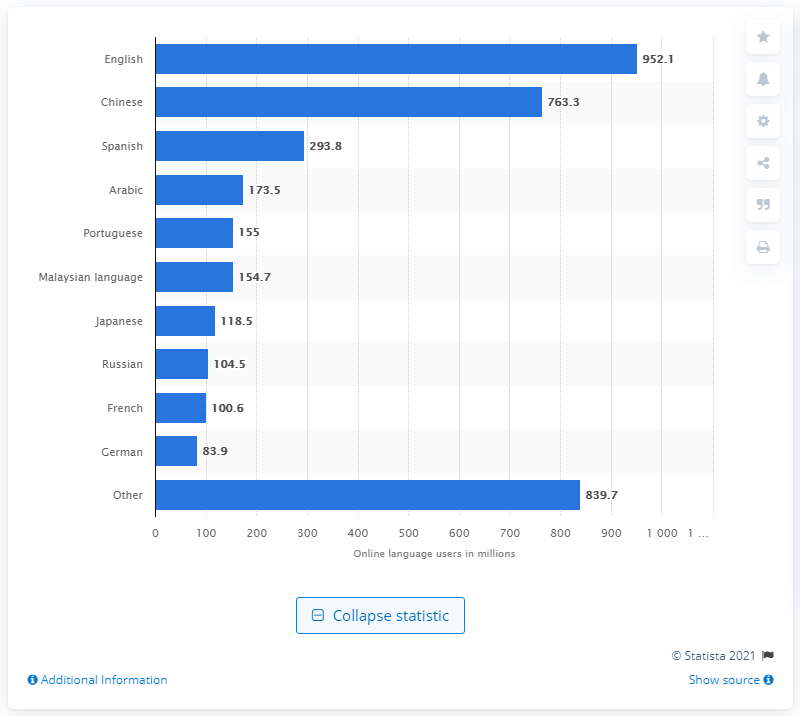What does this chart reveal about the prevalence of languages other than English online? The chart clearly shows that while English dominates as the most used language online, other languages such as Chinese and Spanish also have a substantial presence, with 763.3 million and 293.8 million users respectively. This reflects a significant diversity in language usage on the internet, mirroring global linguistic and cultural diversity. Why might it be significant that languages like Arabic and Portuguese have over 100 million speakers online as shown on the chart? Languages like Arabic and Portuguese having over 100 million online users is significant as it indicates not only the diverse nature of online communities but also the potential market and cultural influence these language groups wield in the digital sphere. For businesses and content creators, these are crucial demographics for targeted communications and services. 